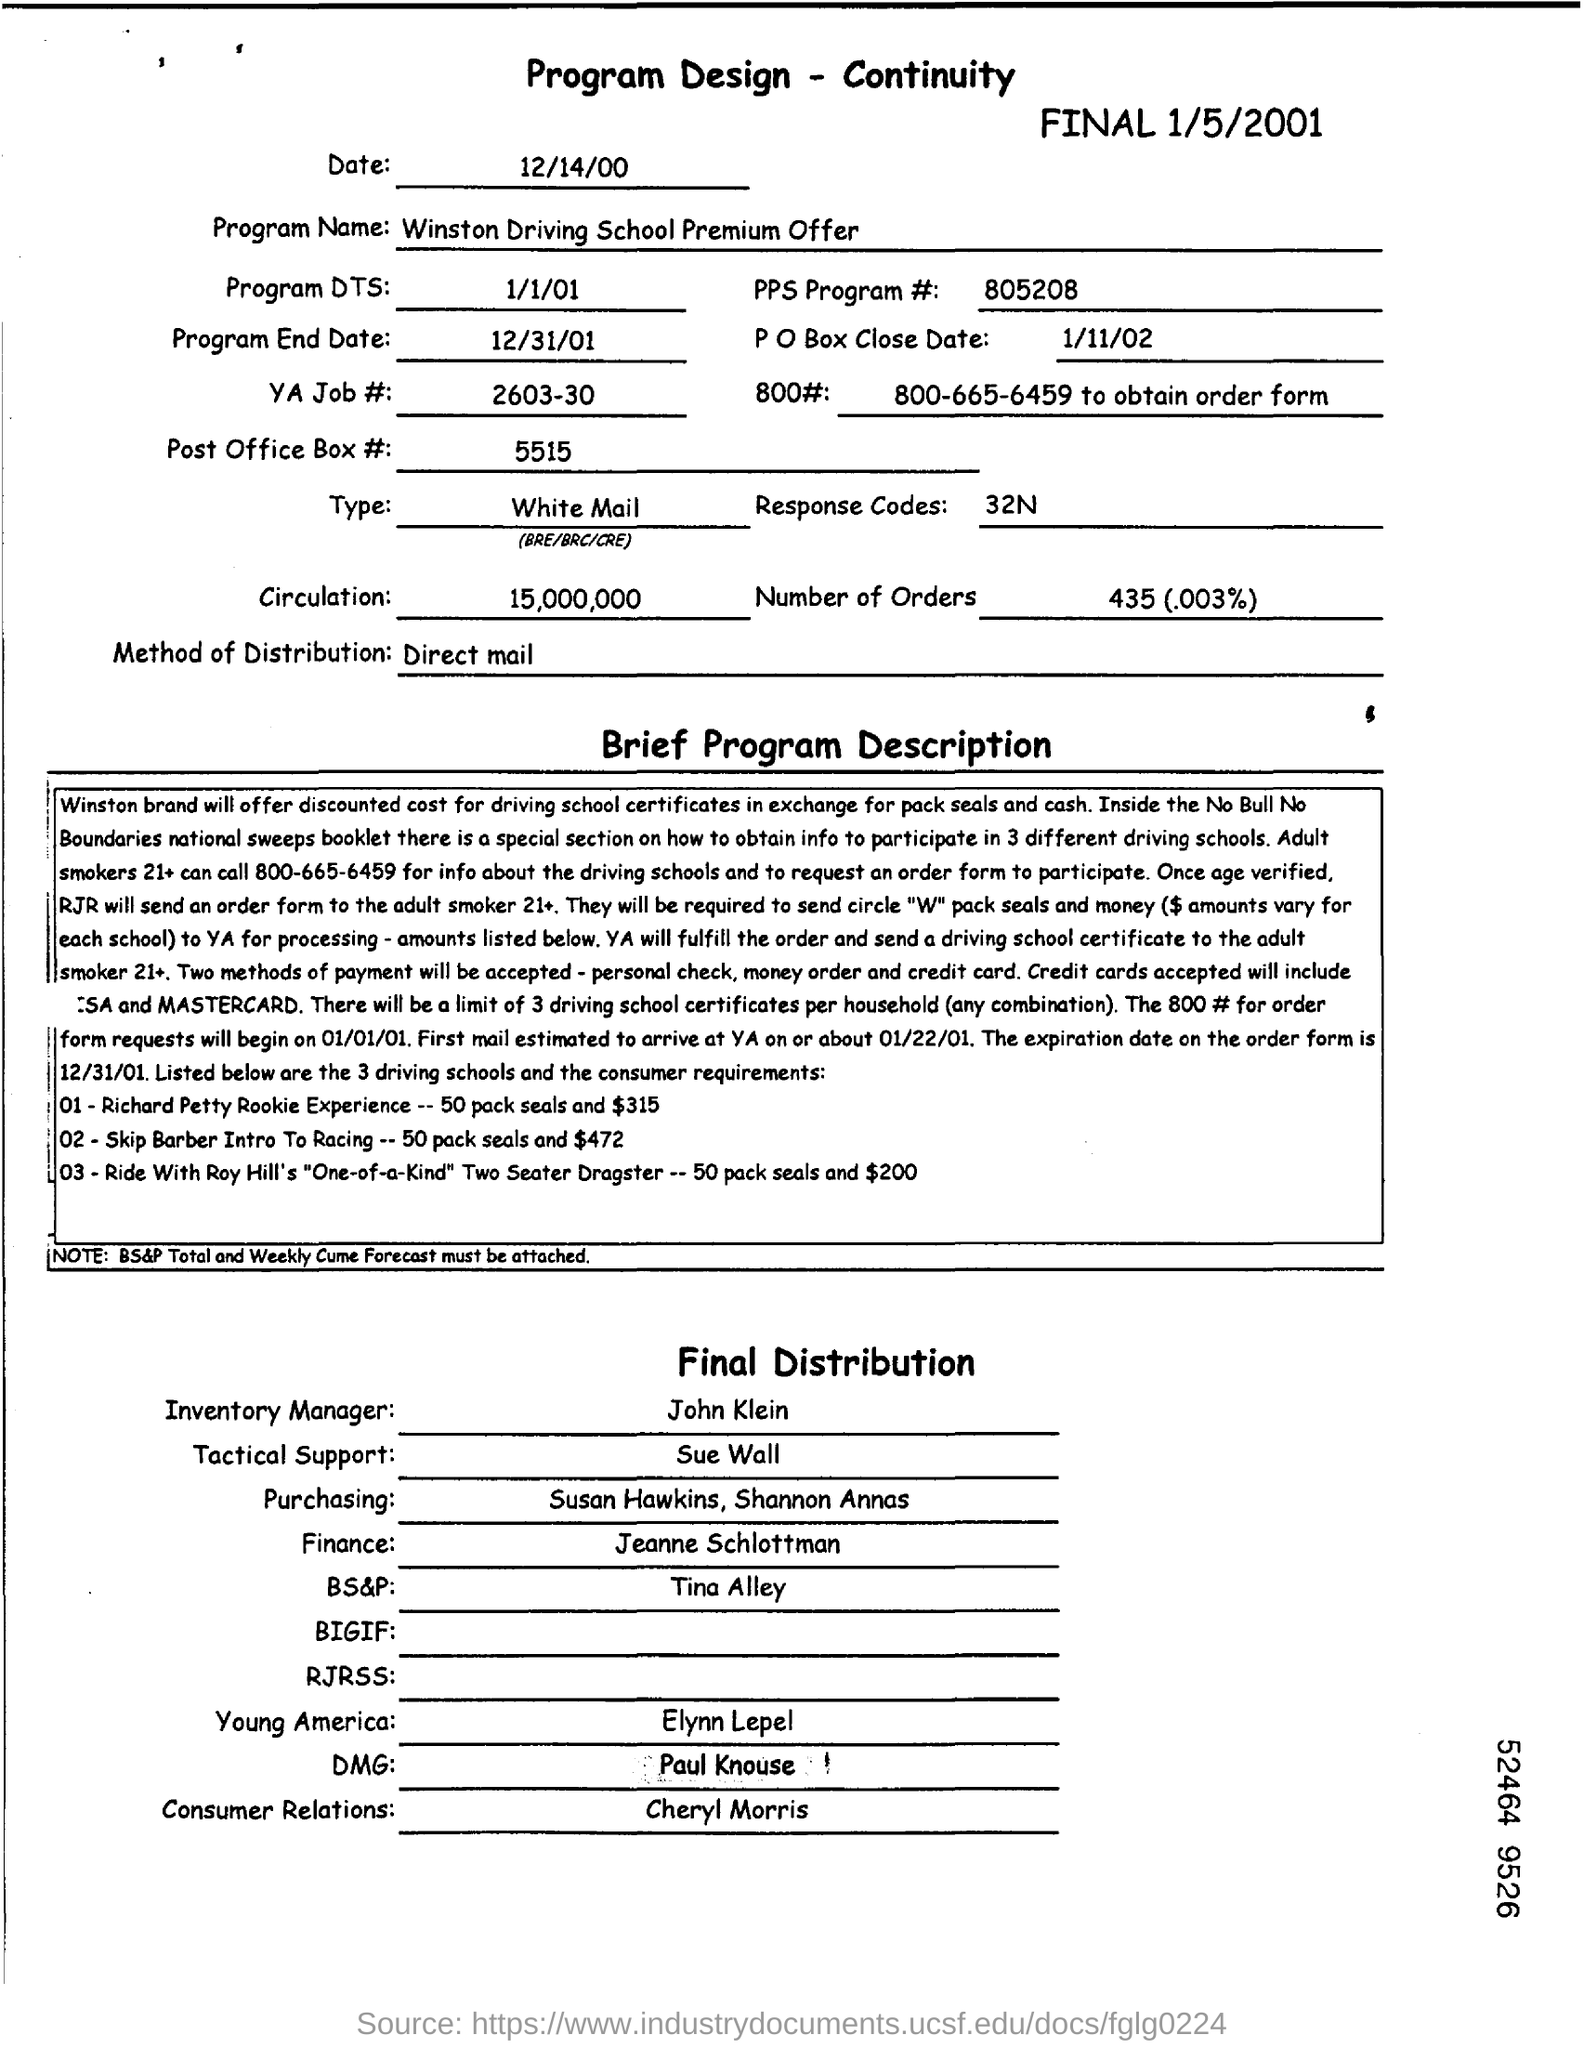What is the heading of the document?
Give a very brief answer. Program Design - Continuity. Who is the Inventory Manager?
Ensure brevity in your answer.  John Klein. What is the Date mentioned?
Give a very brief answer. 12/14/00. What is the YA JOB # ?
Your answer should be very brief. 2603-30. What is PPS Program #?
Offer a terse response. 805208. What is the program end date?
Offer a terse response. 12/31/01. What is the method of distribution?
Provide a short and direct response. Direct mail. 